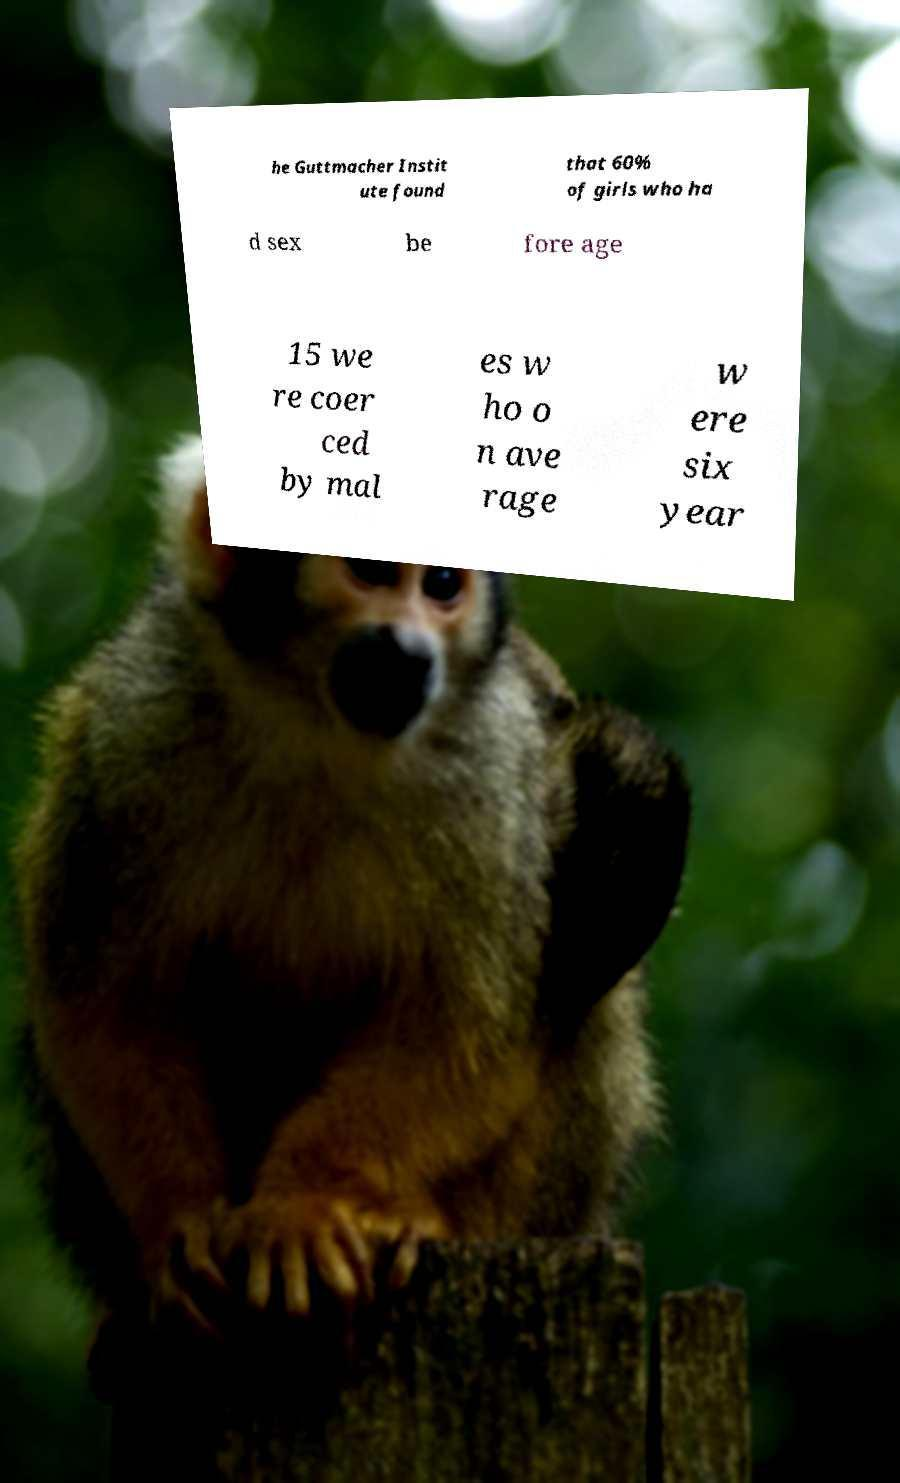For documentation purposes, I need the text within this image transcribed. Could you provide that? he Guttmacher Instit ute found that 60% of girls who ha d sex be fore age 15 we re coer ced by mal es w ho o n ave rage w ere six year 